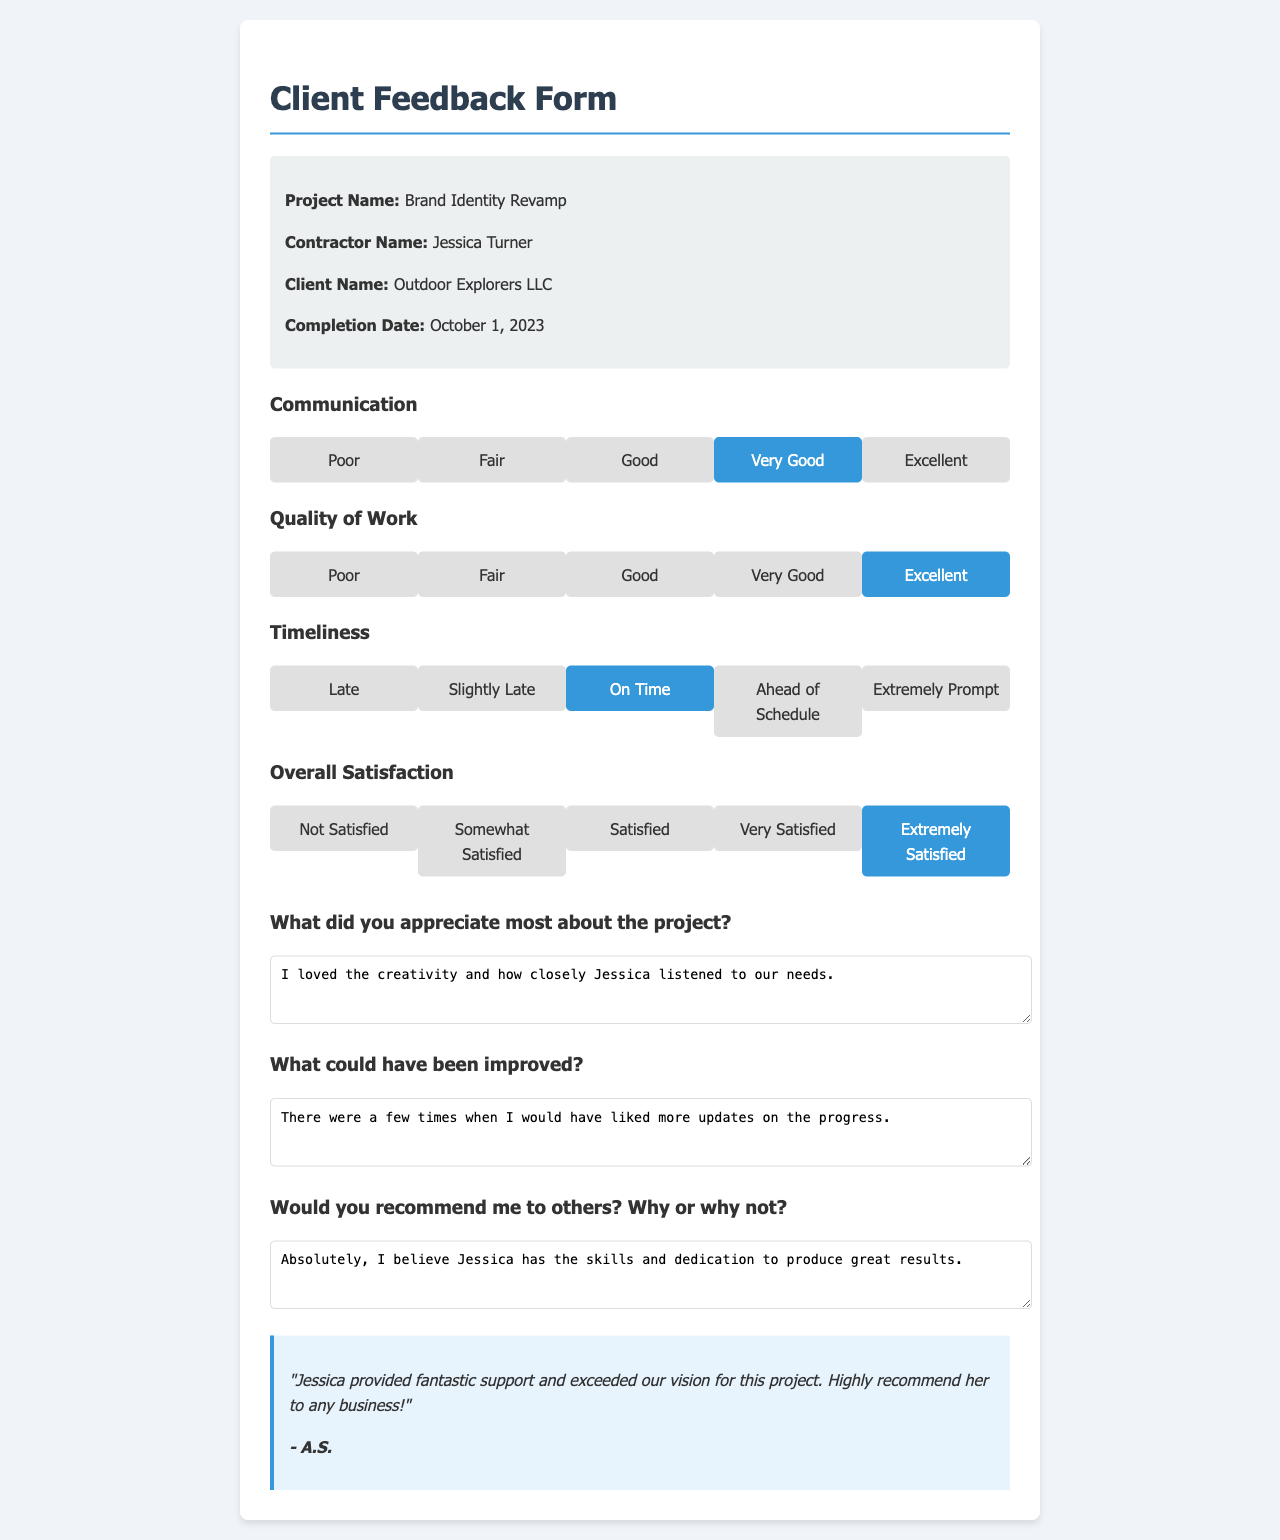What is the project name? The project name is stated at the top of the document as "Brand Identity Revamp."
Answer: Brand Identity Revamp Who is the contractor's name? The contractor's name is provided in the project details section of the document, which is "Jessica Turner."
Answer: Jessica Turner What date was the project completed? The completion date is noted in the document, which is "October 1, 2023."
Answer: October 1, 2023 How did the client rate the communication? The rating for communication can be found in the section where the client selected a radio button, which shows "Very Good."
Answer: Very Good What did the client appreciate most about the project? This information is provided in the comments section of the document, indicating the client's appreciation such as creativity and listening to needs.
Answer: I loved the creativity and how closely Jessica listened to our needs Would the client recommend the contractor to others? This answer is found in the comments, where the client states their willingness to recommend, explaining why or why not.
Answer: Absolutely, I believe Jessica has the skills and dedication to produce great results 